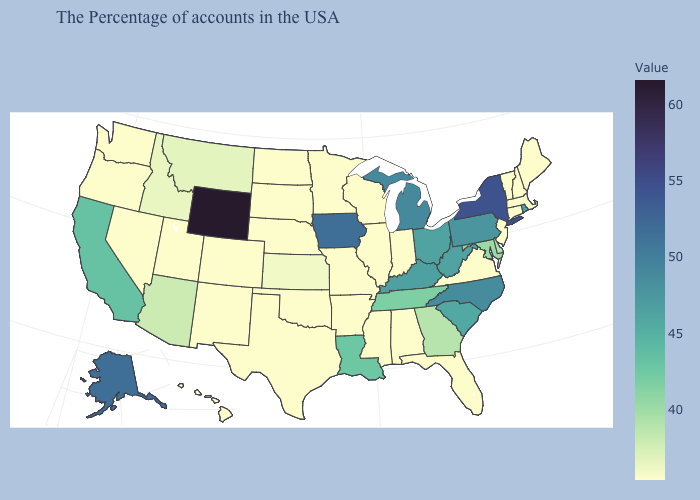Which states hav the highest value in the South?
Write a very short answer. North Carolina. Does the map have missing data?
Keep it brief. No. Among the states that border Wyoming , which have the highest value?
Short answer required. Montana. Does Arkansas have the highest value in the South?
Concise answer only. No. Among the states that border Washington , does Idaho have the lowest value?
Keep it brief. No. Does Texas have a higher value than New York?
Give a very brief answer. No. Does the map have missing data?
Be succinct. No. 